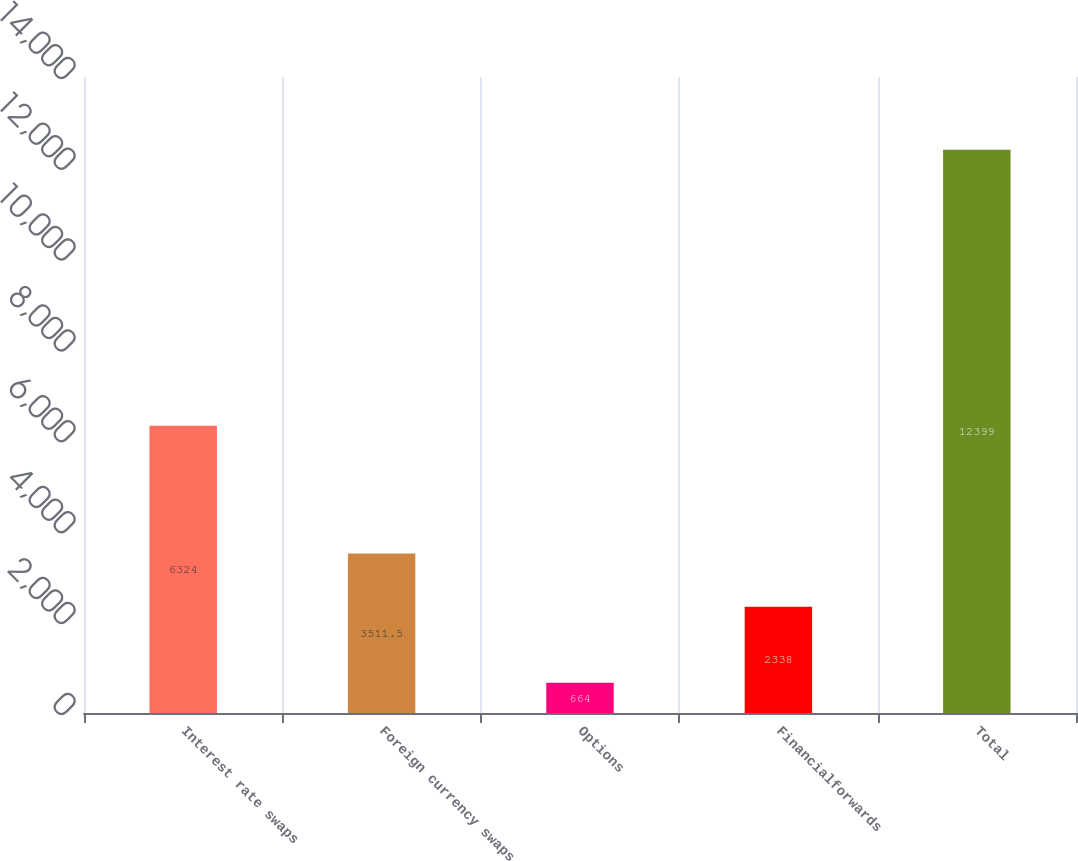Convert chart. <chart><loc_0><loc_0><loc_500><loc_500><bar_chart><fcel>Interest rate swaps<fcel>Foreign currency swaps<fcel>Options<fcel>Financialforwards<fcel>Total<nl><fcel>6324<fcel>3511.5<fcel>664<fcel>2338<fcel>12399<nl></chart> 